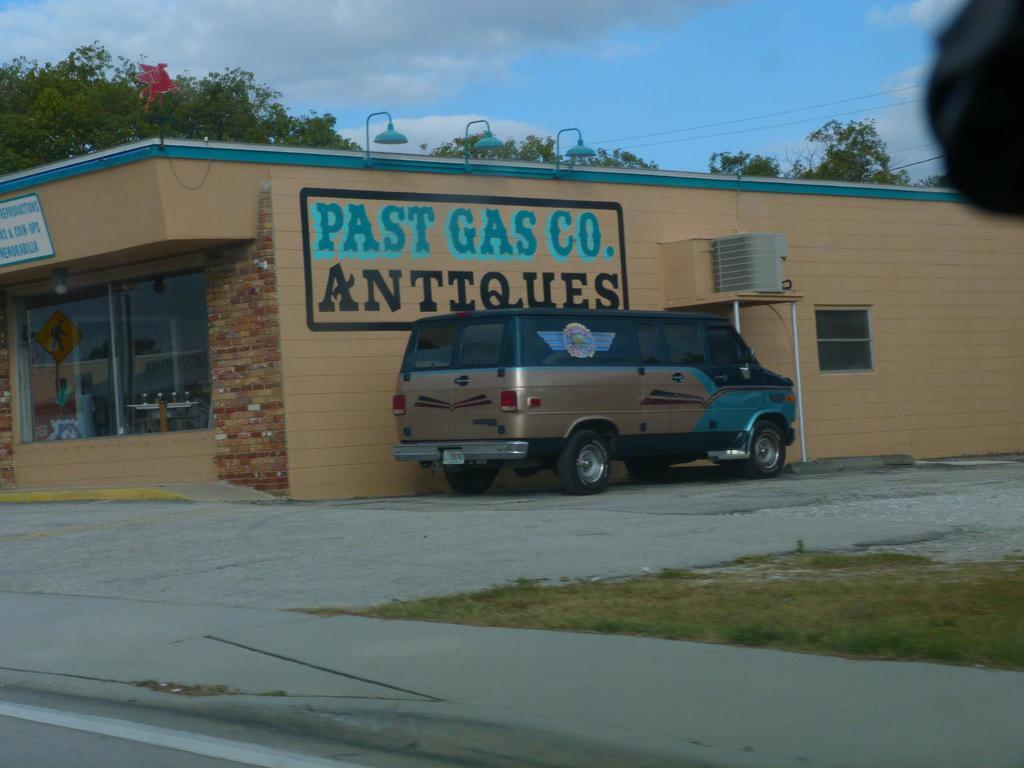<image>
Share a concise interpretation of the image provided. A van is parked next to a building with "Past Gas Co, Antiques" painted on the side of the building. 